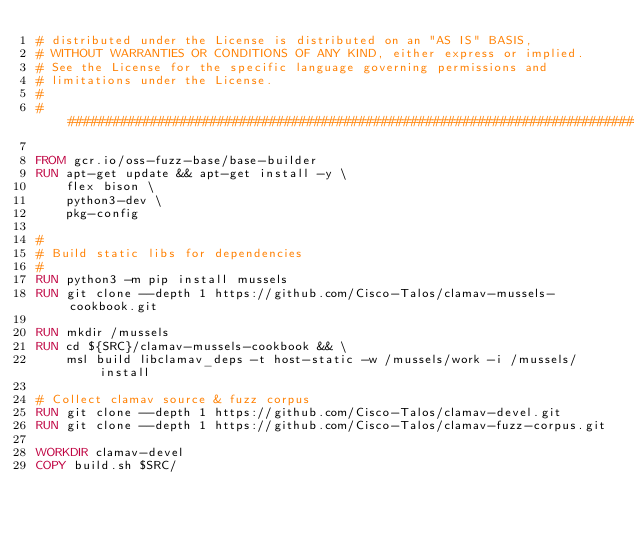Convert code to text. <code><loc_0><loc_0><loc_500><loc_500><_Dockerfile_># distributed under the License is distributed on an "AS IS" BASIS,
# WITHOUT WARRANTIES OR CONDITIONS OF ANY KIND, either express or implied.
# See the License for the specific language governing permissions and
# limitations under the License.
#
################################################################################

FROM gcr.io/oss-fuzz-base/base-builder
RUN apt-get update && apt-get install -y \
    flex bison \
    python3-dev \
    pkg-config

#
# Build static libs for dependencies
#
RUN python3 -m pip install mussels
RUN git clone --depth 1 https://github.com/Cisco-Talos/clamav-mussels-cookbook.git

RUN mkdir /mussels
RUN cd ${SRC}/clamav-mussels-cookbook && \
    msl build libclamav_deps -t host-static -w /mussels/work -i /mussels/install

# Collect clamav source & fuzz corpus
RUN git clone --depth 1 https://github.com/Cisco-Talos/clamav-devel.git
RUN git clone --depth 1 https://github.com/Cisco-Talos/clamav-fuzz-corpus.git

WORKDIR clamav-devel
COPY build.sh $SRC/
</code> 